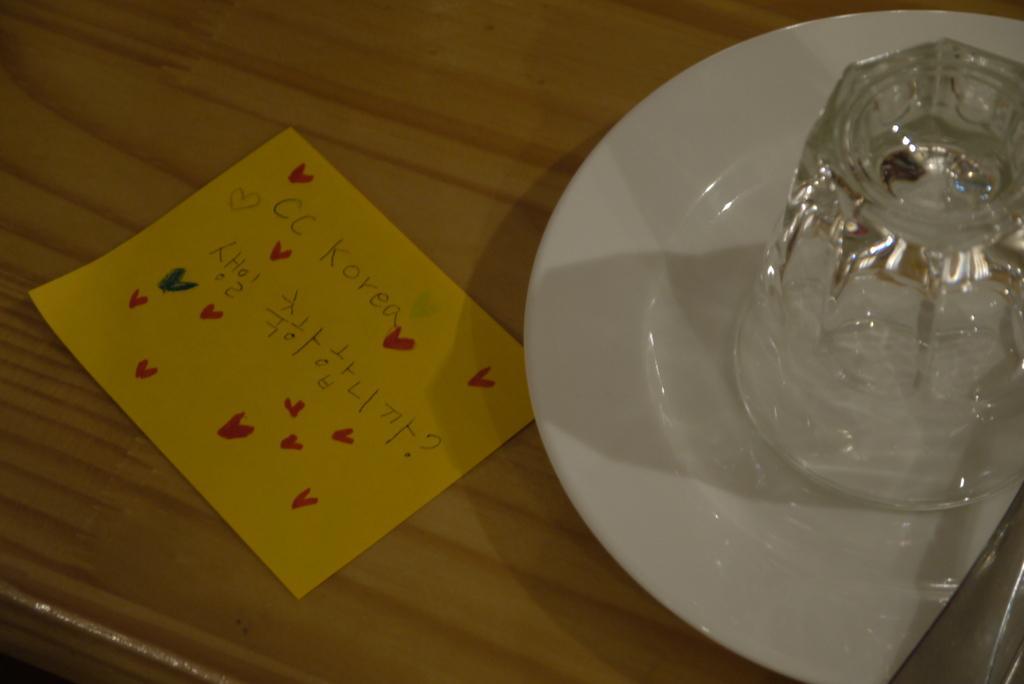Can you describe this image briefly? In this picture we can see a wooden platform. On a wooden platform we can see a paper note with some information. On the right side of the picture we can see a plate, glass and an object. 